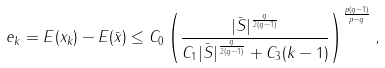<formula> <loc_0><loc_0><loc_500><loc_500>e _ { k } = E ( x _ { k } ) - E ( \bar { x } ) \leq C _ { 0 } \left ( \frac { | \bar { S } | ^ { \frac { q } { 2 ( q - 1 ) } } } { C _ { 1 } | \bar { S } | ^ { \frac { q } { 2 ( q - 1 ) } } + C _ { 3 } ( k - 1 ) } \right ) ^ { \frac { p ( q - 1 ) } { p - q } } ,</formula> 